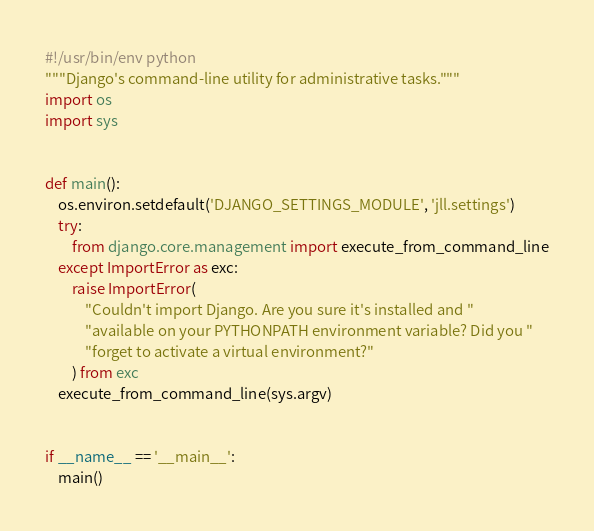<code> <loc_0><loc_0><loc_500><loc_500><_Python_>#!/usr/bin/env python
"""Django's command-line utility for administrative tasks."""
import os
import sys


def main():
    os.environ.setdefault('DJANGO_SETTINGS_MODULE', 'jll.settings')
    try:
        from django.core.management import execute_from_command_line
    except ImportError as exc:
        raise ImportError(
            "Couldn't import Django. Are you sure it's installed and "
            "available on your PYTHONPATH environment variable? Did you "
            "forget to activate a virtual environment?"
        ) from exc
    execute_from_command_line(sys.argv)


if __name__ == '__main__':
    main()
</code> 